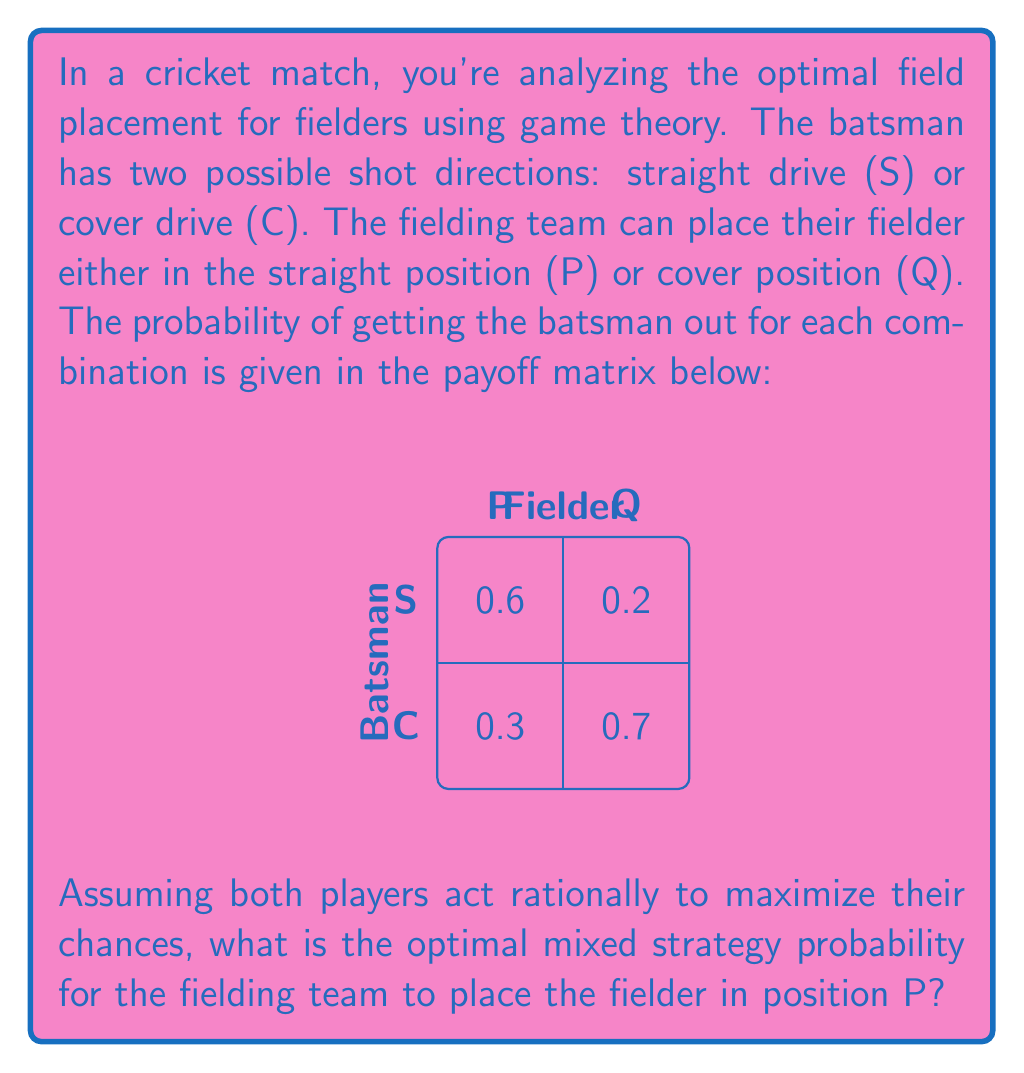Solve this math problem. To solve this problem using game theory, we'll follow these steps:

1) First, we need to convert the payoff matrix to the fielding team's perspective. Since the probabilities represent the chance of getting the batsman out, we'll keep them as is:

   $$
   \begin{matrix}
    & S & C \\
   P & 0.6 & 0.3 \\
   Q & 0.2 & 0.7
   \end{matrix}
   $$

2) Let's define the variables:
   - $p$ = probability of fielder being placed in position P
   - $1-p$ = probability of fielder being placed in position Q
   - $q$ = probability of batsman playing straight drive (S)
   - $1-q$ = probability of batsman playing cover drive (C)

3) The expected payoff for the fielding team is:

   $E = 0.6pq + 0.3p(1-q) + 0.2(1-p)q + 0.7(1-p)(1-q)$

4) For a mixed strategy equilibrium, the expected payoff should be the same regardless of the batsman's choice. So we equate the payoffs:

   $0.6p + 0.2(1-p) = 0.3p + 0.7(1-p)$

5) Simplify:
   $0.6p + 0.2 - 0.2p = 0.3p + 0.7 - 0.7p$
   $0.4p + 0.2 = -0.4p + 0.7$
   $0.8p = 0.5$

6) Solve for $p$:
   $p = 0.5 / 0.8 = 0.625$

Therefore, the optimal strategy for the fielding team is to place the fielder in position P with a probability of 0.625 (62.5%) and in position Q with a probability of 0.375 (37.5%).
Answer: 0.625 